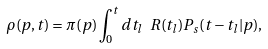<formula> <loc_0><loc_0><loc_500><loc_500>\rho ( p , t ) = \pi ( p ) \int _ { 0 } ^ { t } d t _ { l } \ R ( t _ { l } ) P _ { s } ( t - t _ { l } | p ) ,</formula> 